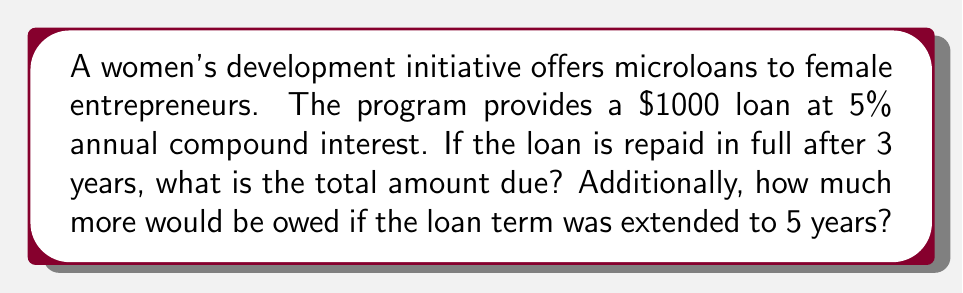Show me your answer to this math problem. To solve this problem, we'll use the compound interest formula:

$$ A = P(1 + r)^t $$

Where:
$A$ = final amount
$P$ = principal (initial loan amount)
$r$ = annual interest rate (as a decimal)
$t$ = time in years

Step 1: Calculate the amount due after 3 years
$$ A_3 = 1000(1 + 0.05)^3 $$
$$ A_3 = 1000(1.05)^3 $$
$$ A_3 = 1000(1.157625) $$
$$ A_3 = 1157.63 $$

Step 2: Calculate the amount due after 5 years
$$ A_5 = 1000(1 + 0.05)^5 $$
$$ A_5 = 1000(1.05)^5 $$
$$ A_5 = 1000(1.276281) $$
$$ A_5 = 1276.28 $$

Step 3: Calculate the difference between 5-year and 3-year repayment
$$ \text{Difference} = A_5 - A_3 $$
$$ \text{Difference} = 1276.28 - 1157.63 $$
$$ \text{Difference} = 118.65 $$
Answer: $1157.63 after 3 years; $118.65 more after 5 years 